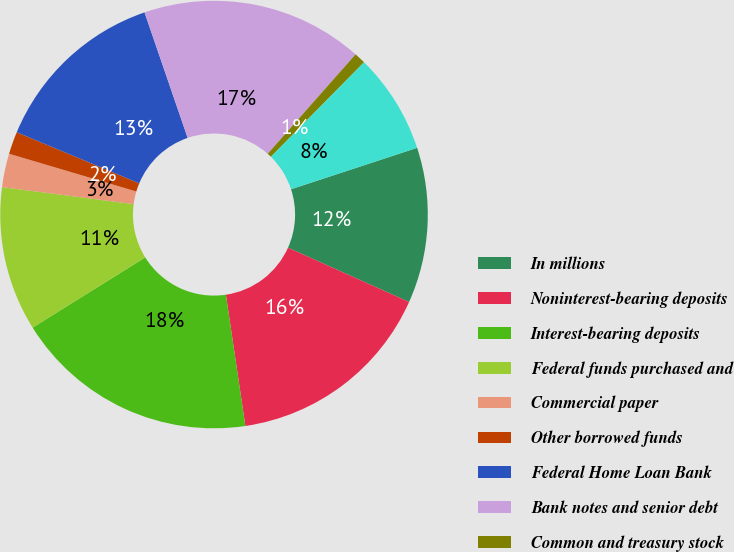Convert chart. <chart><loc_0><loc_0><loc_500><loc_500><pie_chart><fcel>In millions<fcel>Noninterest-bearing deposits<fcel>Interest-bearing deposits<fcel>Federal funds purchased and<fcel>Commercial paper<fcel>Other borrowed funds<fcel>Federal Home Loan Bank<fcel>Bank notes and senior debt<fcel>Common and treasury stock<fcel>Subordinated debt<nl><fcel>11.76%<fcel>15.95%<fcel>18.47%<fcel>10.92%<fcel>2.54%<fcel>1.7%<fcel>13.44%<fcel>16.79%<fcel>0.86%<fcel>7.57%<nl></chart> 